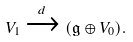<formula> <loc_0><loc_0><loc_500><loc_500>V _ { 1 } \xrightarrow { d } ( \mathfrak { g } \oplus V _ { 0 } ) .</formula> 